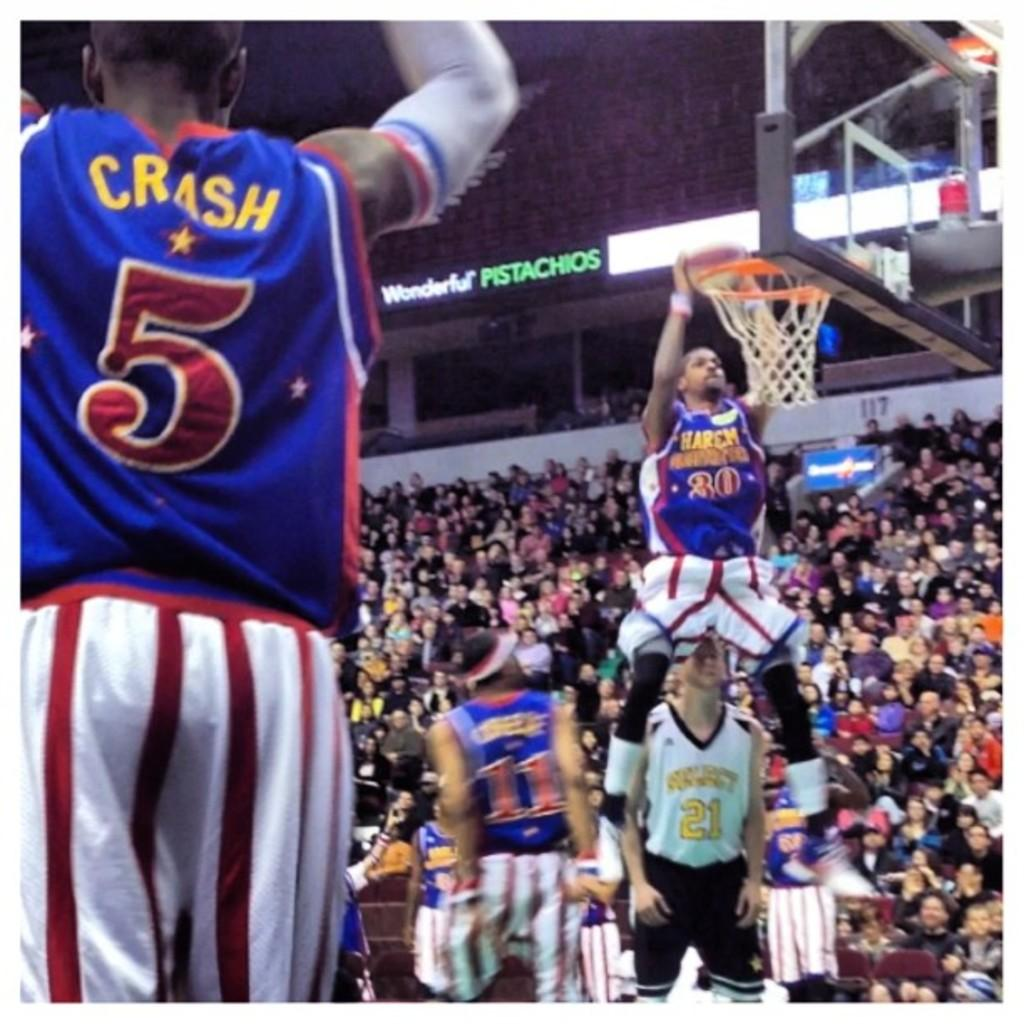<image>
Describe the image concisely. The Harlem Globetrotters put on a show in front of tons of fans. 